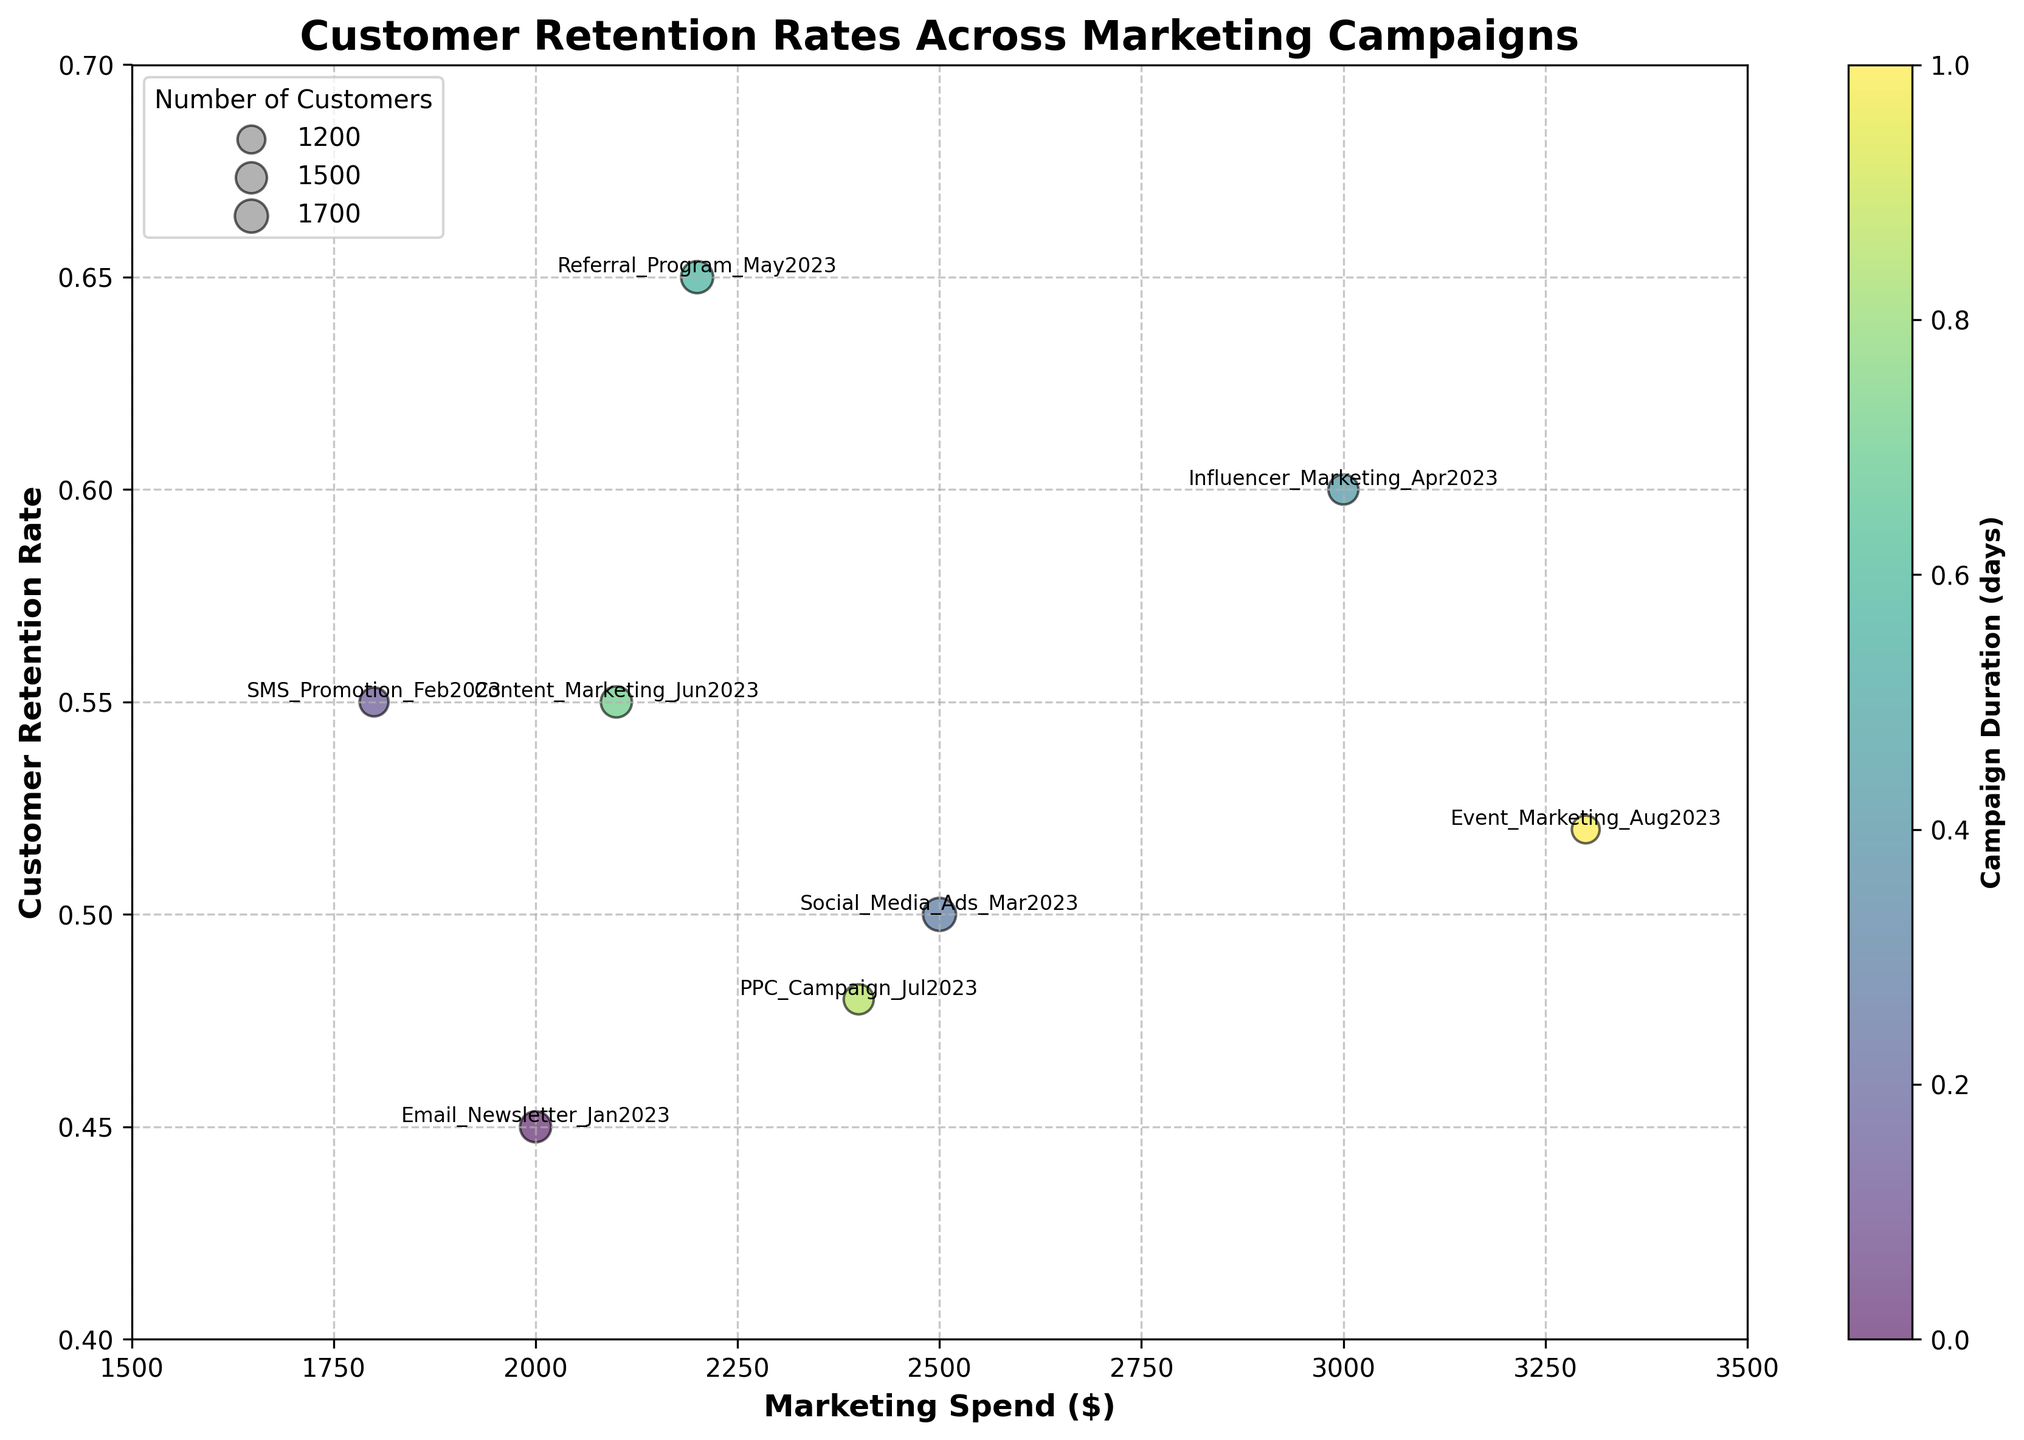How many marketing campaigns are displayed in the chart? There are eight campaigns listed in the data table under the 'Marketing_Campaign' column, and each one is displayed as a bubble in the chart
Answer: Eight Which marketing campaign has the highest customer retention rate? By observing the y-axis, the campaign 'Referral Program May2023' has the highest retention rate of 0.65, which is the highest point on the y-axis.
Answer: Referral Program May2023 What is the relationship between marketing spend and customer retention rate for the Social Media Ads Mar2023 campaign? For the Social Media Ads Mar2023 campaign, the marketing spend is $2500 and the customer retention rate is 0.50. The bubble can be found by looking at the intersection of the marketing spend and the retention rate on the chart.
Answer: Marketing Spend: $2500, Customer Retention Rate: 0.50 Which campaign had the highest number of customers? By observing the size of the bubbles, 'Social Media Ads Mar2023' has the largest bubble, indicating it had the most number of customers.
Answer: Social Media Ads Mar2023 How do the retention rates for Email Newsletter Jan2023 and SMS Promotion Feb2023 compare? By looking at the y-axis positions of these two campaigns' bubbles, Email Newsletter Jan2023 has a retention rate of 0.45 while SMS Promotion Feb2023 has a retention rate of 0.55. The retention rate for SMS Promotion Feb2023 is higher than that for Email Newsletter Jan2023.
Answer: SMS Promotion Feb2023 > Email Newsletter Jan2023 For which campaigns does an increase in marketing spend does not co-relate to a higher customer retention rate? By observing the scatter plot visually, 'Event Marketing Aug2023' with $3300 spend has a retention rate of 0.52 which is lower than campaigns with lesser spend like 'Referral Program May2023' with $2200 spend and a higher retention rate of 0.65.
Answer: Event Marketing Aug2023 vs Referral Program May2023 What is the average customer retention rate across all campaigns? Sum up all the customer retention rates (0.45, 0.55, 0.50, 0.60, 0.65, 0.55, 0.48, 0.52) which equals 4.30, then divide by the number of campaigns (8). Average = 4.30 / 8 = 0.5375.
Answer: 0.5375 Which marketing campaign had the shortest duration? By observing the color bar, the campaign with the darkest color represents the shortest duration, which is 'Event Marketing Aug2023' with a duration of 10 days.
Answer: Event Marketing Aug2023 